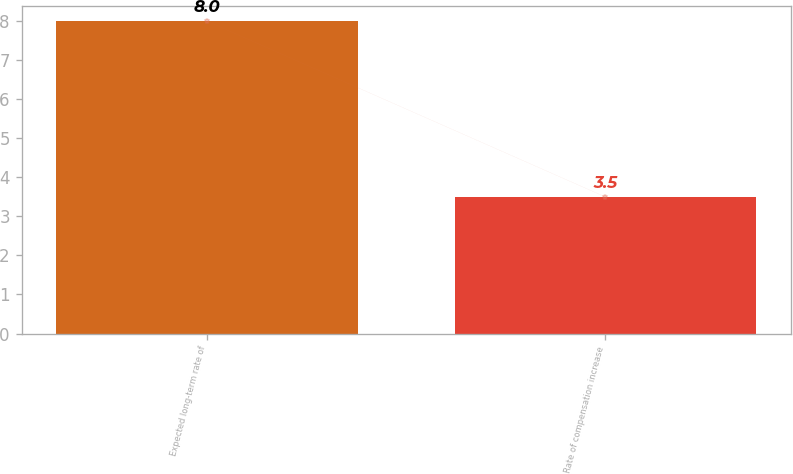<chart> <loc_0><loc_0><loc_500><loc_500><bar_chart><fcel>Expected long-term rate of<fcel>Rate of compensation increase<nl><fcel>8<fcel>3.5<nl></chart> 